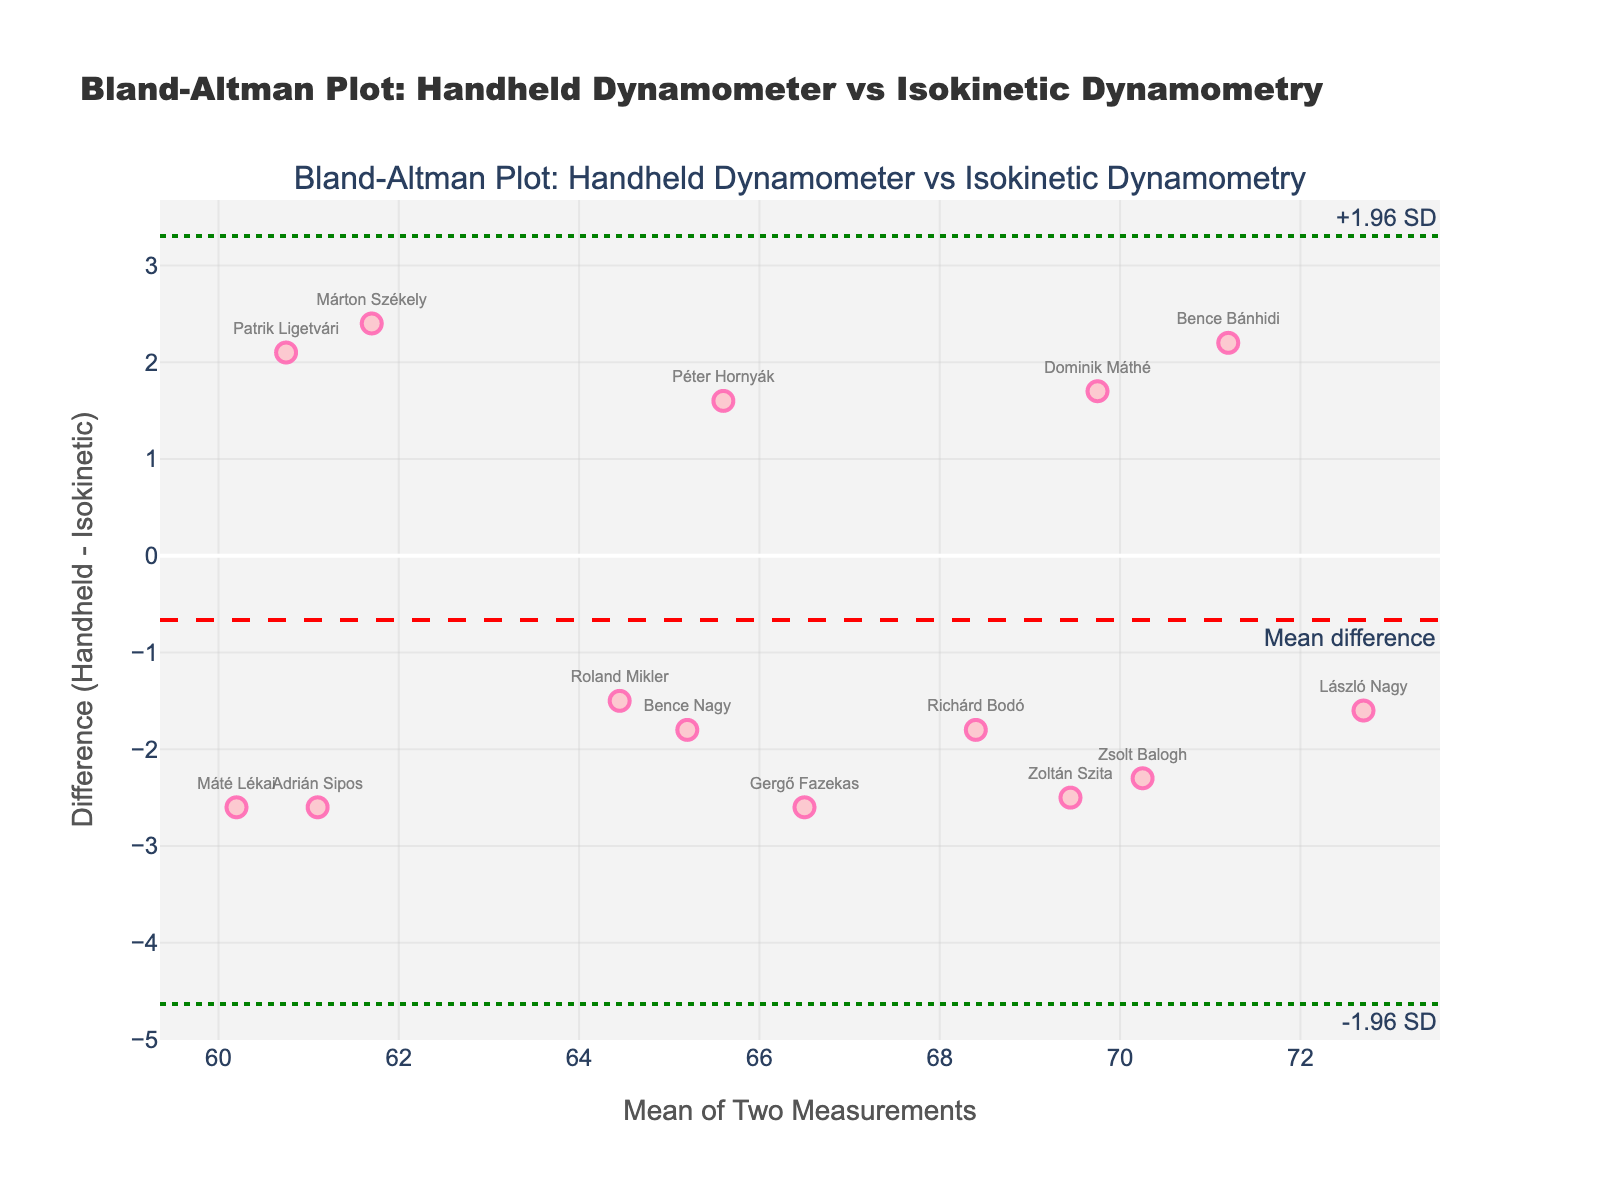how many data points are present in the Bland–Altman plot? To find the number of data points, count the markers on the plot, each representing a player. In this case, you can count 14 data points representing 14 players.
Answer: 14 What is the average difference between the handheld dynamometer and isokinetic dynamometry measurements? To determine the average difference, locate the mean difference line on the plot, which is annotated with "Mean difference." The value is visually represented on the y-axis where this line intersects. This line is at the value -0.314.
Answer: -0.314 What is the upper limit of agreement? The upper limit of agreement is annotated on the plot as "+1.96 SD" and is represented by a horizontal dotted green line. The value can be read directly from the y-axis where this line intersects, which is approximately 2.633.
Answer: 2.633 Which player has the largest positive difference between the handheld dynamometer and isokinetic dynamometry measurements? Identify the point with the highest positive y-value (difference) on the plot. The player name closest to the highest point is "Patrik Ligetvári."
Answer: Patrik Ligetvári Which player has the largest difference in the negative direction? Identify the point with the lowest negative y-value (difference) on the plot. The player name closest to the lowest point is "Bence Bánhidi."
Answer: Bence Bánhidi Is the measurement difference generally higher for players with higher mean measurements or lower mean measurements? Examine the plot to observe the pattern of points. Generally, if points with higher mean values (x-axis) tend to have higher differences (y-axis), then the difference is higher for players with higher mean measurements; otherwise, it's not. In this plot, there is no clear trend indicating higher differences at higher or lower mean measurements.
Answer: No clear trend How many players fall outside the limits of agreement? Count the data points that lie above the upper limit or below the lower limit of agreement (represented as "1.96 SD" and "-1.96 SD" respectively). In the plot, there is 1 player above the upper limit and no players below the lower limit.
Answer: 1 What is the range of the mean values of the two measurements? The range is found by identifying the minimum and maximum values on the x-axis where the data points are plotted. The minimum mean is approximately 60.5, and the maximum mean is approximately 72.7.
Answer: 60.5 to 72.7 Which player has a mean measurement closest to 65? Identify the point on the plot nearest the x-axis value of 65. The player name closest to this point is "Roland Mikler."
Answer: Roland Mikler 